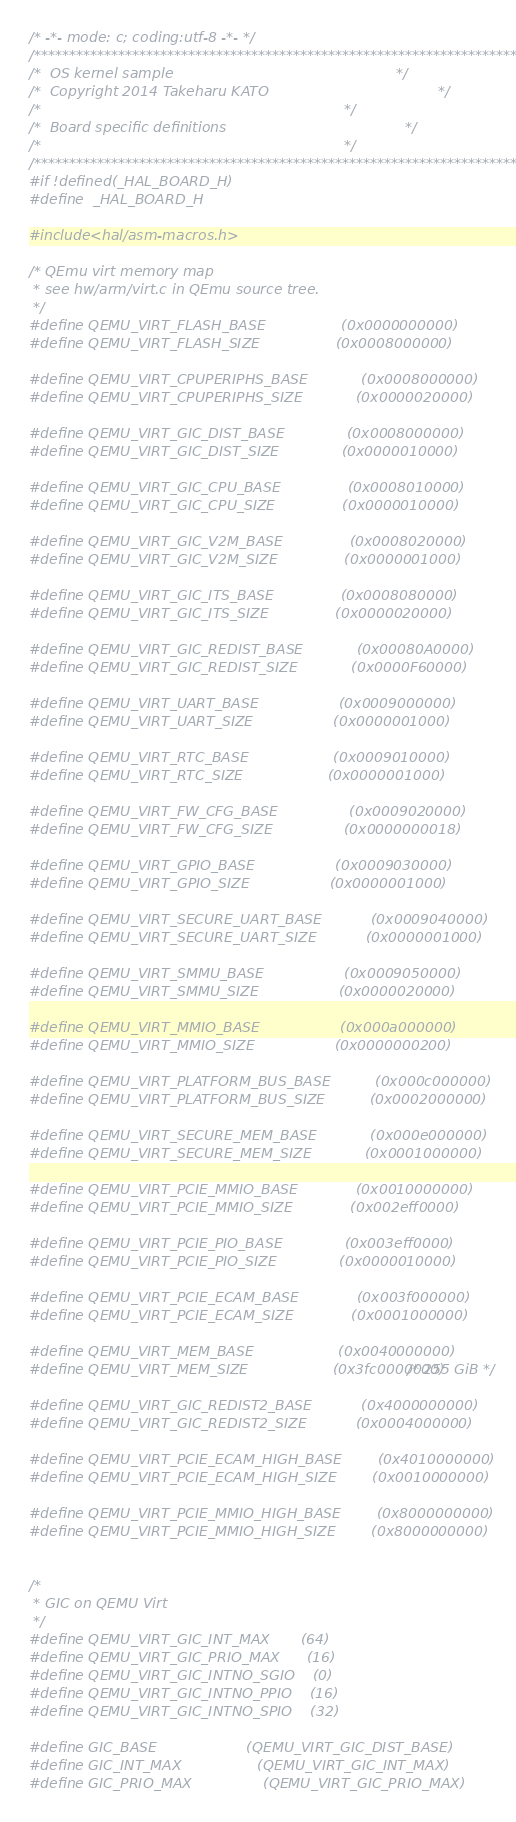Convert code to text. <code><loc_0><loc_0><loc_500><loc_500><_C_>/* -*- mode: c; coding:utf-8 -*- */
/**********************************************************************/
/*  OS kernel sample                                                  */
/*  Copyright 2014 Takeharu KATO                                      */
/*                                                                    */
/*  Board specific definitions                                        */
/*                                                                    */
/**********************************************************************/
#if !defined(_HAL_BOARD_H)
#define  _HAL_BOARD_H 

#include <hal/asm-macros.h>

/* QEmu virt memory map
 * see hw/arm/virt.c in QEmu source tree.
 */
#define QEMU_VIRT_FLASH_BASE                 (0x0000000000)
#define QEMU_VIRT_FLASH_SIZE                 (0x0008000000)

#define QEMU_VIRT_CPUPERIPHS_BASE            (0x0008000000)
#define QEMU_VIRT_CPUPERIPHS_SIZE            (0x0000020000)

#define QEMU_VIRT_GIC_DIST_BASE              (0x0008000000)
#define QEMU_VIRT_GIC_DIST_SIZE              (0x0000010000)

#define QEMU_VIRT_GIC_CPU_BASE               (0x0008010000)
#define QEMU_VIRT_GIC_CPU_SIZE               (0x0000010000)

#define QEMU_VIRT_GIC_V2M_BASE               (0x0008020000)
#define QEMU_VIRT_GIC_V2M_SIZE               (0x0000001000)

#define QEMU_VIRT_GIC_ITS_BASE               (0x0008080000)
#define QEMU_VIRT_GIC_ITS_SIZE               (0x0000020000)

#define QEMU_VIRT_GIC_REDIST_BASE            (0x00080A0000)
#define QEMU_VIRT_GIC_REDIST_SIZE            (0x0000F60000)

#define QEMU_VIRT_UART_BASE                  (0x0009000000)
#define QEMU_VIRT_UART_SIZE                  (0x0000001000)

#define QEMU_VIRT_RTC_BASE                   (0x0009010000)
#define QEMU_VIRT_RTC_SIZE                   (0x0000001000)

#define QEMU_VIRT_FW_CFG_BASE                (0x0009020000)
#define QEMU_VIRT_FW_CFG_SIZE                (0x0000000018)

#define QEMU_VIRT_GPIO_BASE                  (0x0009030000)
#define QEMU_VIRT_GPIO_SIZE                  (0x0000001000)

#define QEMU_VIRT_SECURE_UART_BASE           (0x0009040000)
#define QEMU_VIRT_SECURE_UART_SIZE           (0x0000001000)

#define QEMU_VIRT_SMMU_BASE                  (0x0009050000)
#define QEMU_VIRT_SMMU_SIZE                  (0x0000020000)

#define QEMU_VIRT_MMIO_BASE                  (0x000a000000)
#define QEMU_VIRT_MMIO_SIZE                  (0x0000000200)

#define QEMU_VIRT_PLATFORM_BUS_BASE          (0x000c000000)
#define QEMU_VIRT_PLATFORM_BUS_SIZE          (0x0002000000)

#define QEMU_VIRT_SECURE_MEM_BASE            (0x000e000000)
#define QEMU_VIRT_SECURE_MEM_SIZE            (0x0001000000)

#define QEMU_VIRT_PCIE_MMIO_BASE             (0x0010000000)
#define QEMU_VIRT_PCIE_MMIO_SIZE             (0x002eff0000)

#define QEMU_VIRT_PCIE_PIO_BASE              (0x003eff0000)
#define QEMU_VIRT_PCIE_PIO_SIZE              (0x0000010000)

#define QEMU_VIRT_PCIE_ECAM_BASE             (0x003f000000)
#define QEMU_VIRT_PCIE_ECAM_SIZE             (0x0001000000)
                                                  
#define QEMU_VIRT_MEM_BASE                   (0x0040000000)
#define QEMU_VIRT_MEM_SIZE                   (0x3fc0000000) /* 255 GiB */

#define QEMU_VIRT_GIC_REDIST2_BASE           (0x4000000000)
#define QEMU_VIRT_GIC_REDIST2_SIZE           (0x0004000000)

#define QEMU_VIRT_PCIE_ECAM_HIGH_BASE        (0x4010000000)
#define QEMU_VIRT_PCIE_ECAM_HIGH_SIZE        (0x0010000000)

#define QEMU_VIRT_PCIE_MMIO_HIGH_BASE        (0x8000000000)
#define QEMU_VIRT_PCIE_MMIO_HIGH_SIZE        (0x8000000000)


/*
 * GIC on QEMU Virt 
 */
#define QEMU_VIRT_GIC_INT_MAX       (64)
#define QEMU_VIRT_GIC_PRIO_MAX      (16)
#define QEMU_VIRT_GIC_INTNO_SGIO    (0)
#define QEMU_VIRT_GIC_INTNO_PPIO    (16)
#define QEMU_VIRT_GIC_INTNO_SPIO    (32)

#define GIC_BASE                    (QEMU_VIRT_GIC_DIST_BASE)
#define GIC_INT_MAX                 (QEMU_VIRT_GIC_INT_MAX)
#define GIC_PRIO_MAX                (QEMU_VIRT_GIC_PRIO_MAX)</code> 